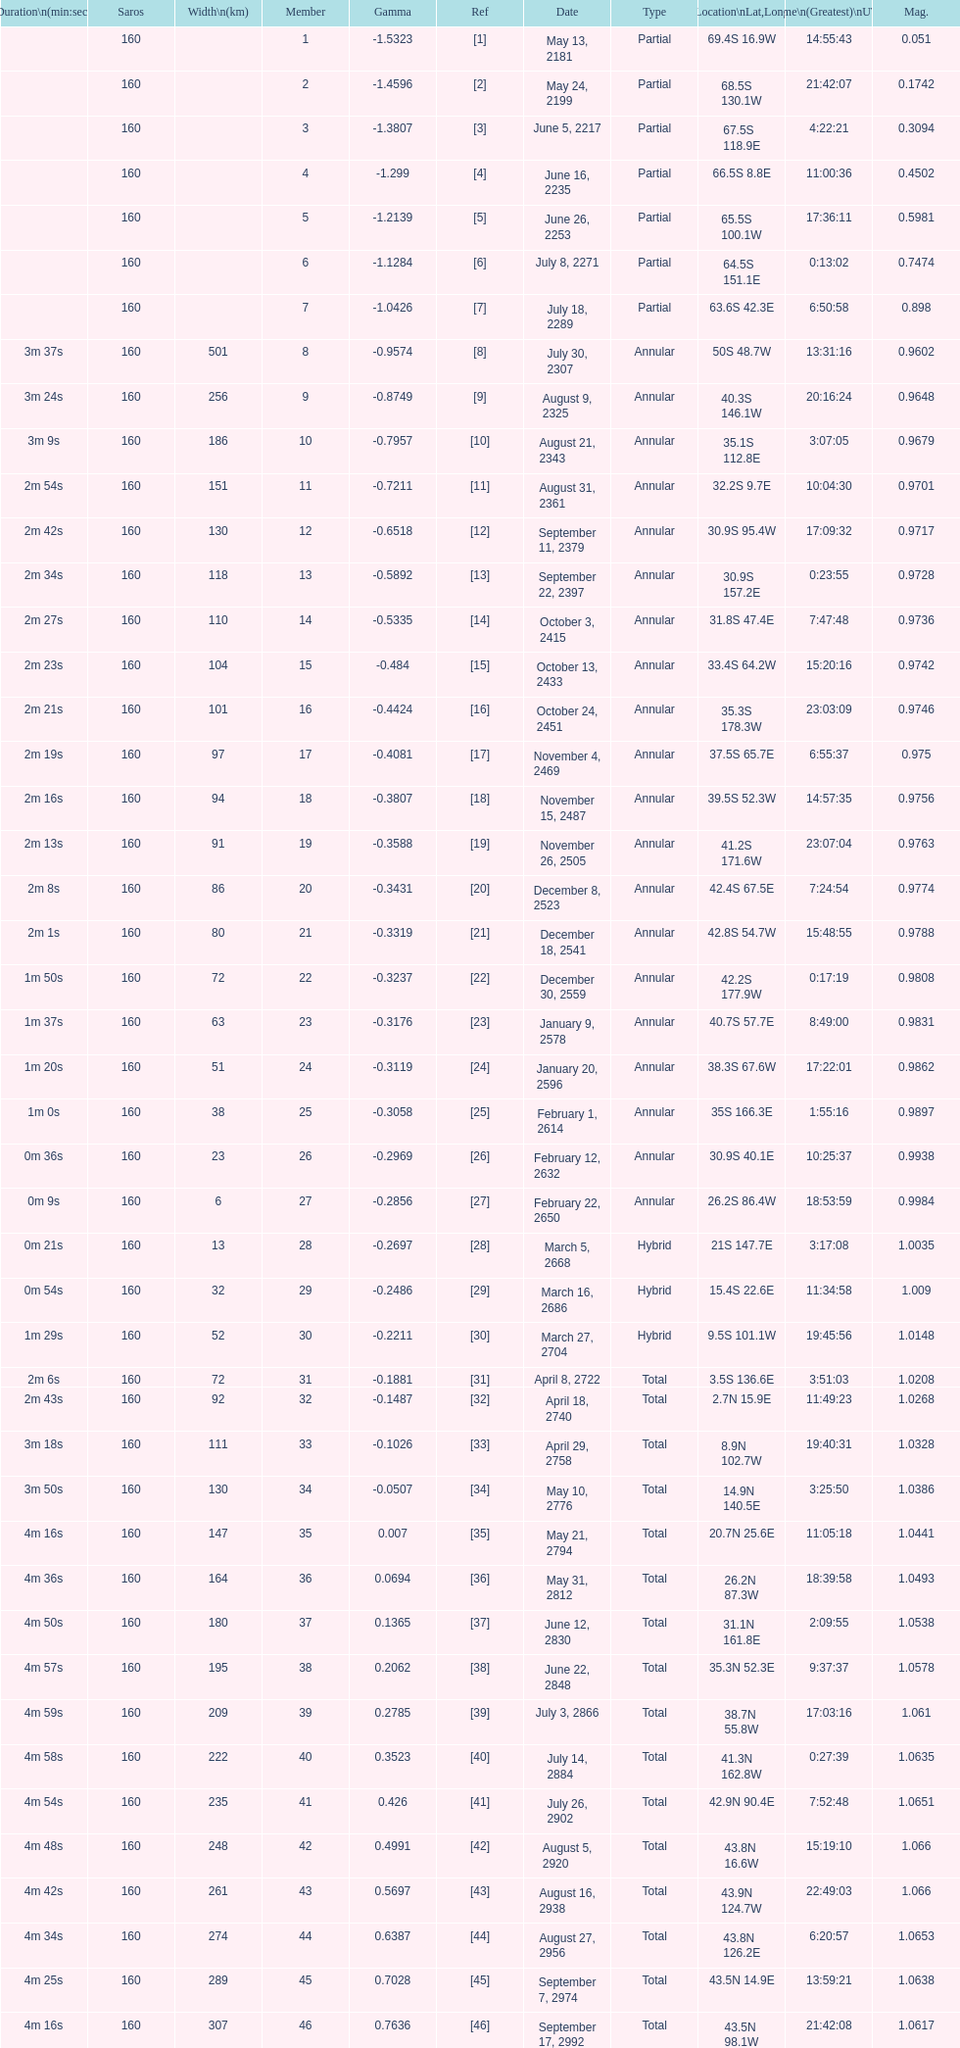What is the difference in magnitude between the may 13, 2181 solar saros and the may 24, 2199 solar saros? 0.1232. 